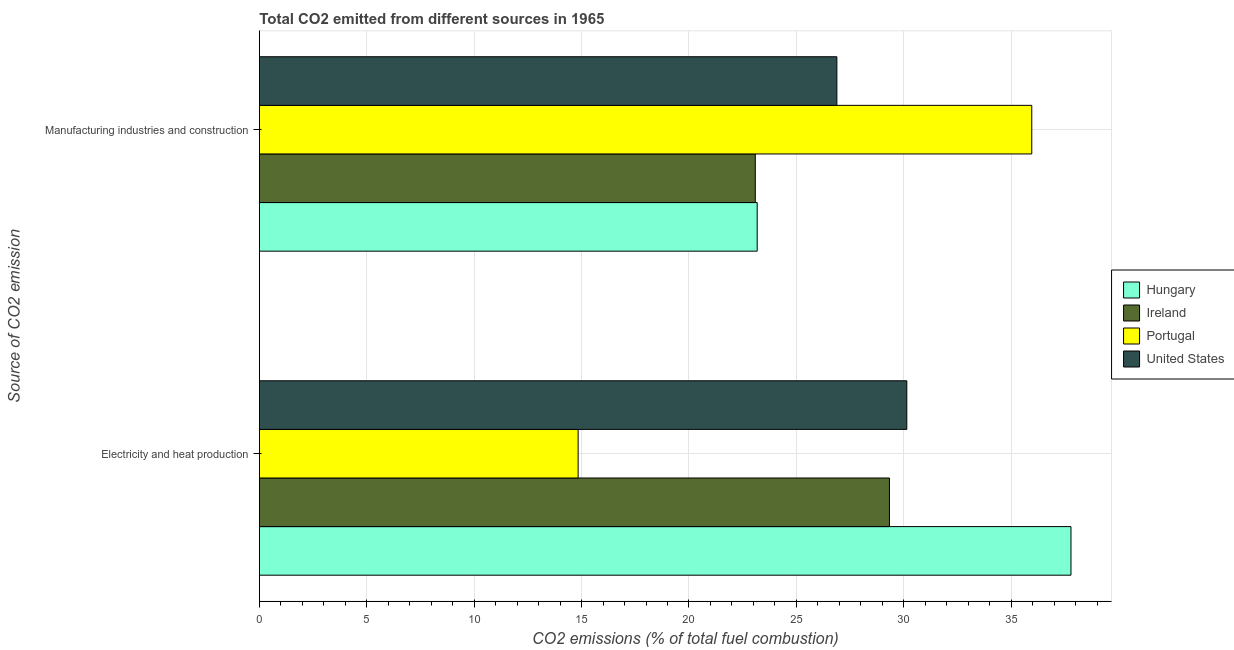How many groups of bars are there?
Provide a short and direct response. 2. How many bars are there on the 2nd tick from the top?
Give a very brief answer. 4. How many bars are there on the 2nd tick from the bottom?
Give a very brief answer. 4. What is the label of the 2nd group of bars from the top?
Offer a terse response. Electricity and heat production. What is the co2 emissions due to electricity and heat production in United States?
Provide a short and direct response. 30.14. Across all countries, what is the maximum co2 emissions due to manufacturing industries?
Your answer should be very brief. 35.96. Across all countries, what is the minimum co2 emissions due to manufacturing industries?
Offer a very short reply. 23.09. In which country was the co2 emissions due to electricity and heat production maximum?
Ensure brevity in your answer.  Hungary. In which country was the co2 emissions due to manufacturing industries minimum?
Provide a succinct answer. Ireland. What is the total co2 emissions due to manufacturing industries in the graph?
Keep it short and to the point. 109.11. What is the difference between the co2 emissions due to electricity and heat production in Ireland and that in United States?
Offer a terse response. -0.81. What is the difference between the co2 emissions due to electricity and heat production in Ireland and the co2 emissions due to manufacturing industries in Portugal?
Offer a terse response. -6.63. What is the average co2 emissions due to manufacturing industries per country?
Ensure brevity in your answer.  27.28. What is the difference between the co2 emissions due to manufacturing industries and co2 emissions due to electricity and heat production in United States?
Offer a very short reply. -3.26. In how many countries, is the co2 emissions due to manufacturing industries greater than 4 %?
Your answer should be compact. 4. What is the ratio of the co2 emissions due to manufacturing industries in Portugal to that in Ireland?
Give a very brief answer. 1.56. Is the co2 emissions due to electricity and heat production in United States less than that in Hungary?
Keep it short and to the point. Yes. What does the 4th bar from the top in Manufacturing industries and construction represents?
Give a very brief answer. Hungary. What does the 4th bar from the bottom in Manufacturing industries and construction represents?
Keep it short and to the point. United States. Are all the bars in the graph horizontal?
Your answer should be compact. Yes. How are the legend labels stacked?
Offer a terse response. Vertical. What is the title of the graph?
Make the answer very short. Total CO2 emitted from different sources in 1965. Does "Mozambique" appear as one of the legend labels in the graph?
Your answer should be compact. No. What is the label or title of the X-axis?
Provide a short and direct response. CO2 emissions (% of total fuel combustion). What is the label or title of the Y-axis?
Provide a short and direct response. Source of CO2 emission. What is the CO2 emissions (% of total fuel combustion) in Hungary in Electricity and heat production?
Give a very brief answer. 37.78. What is the CO2 emissions (% of total fuel combustion) in Ireland in Electricity and heat production?
Ensure brevity in your answer.  29.33. What is the CO2 emissions (% of total fuel combustion) of Portugal in Electricity and heat production?
Provide a succinct answer. 14.84. What is the CO2 emissions (% of total fuel combustion) in United States in Electricity and heat production?
Ensure brevity in your answer.  30.14. What is the CO2 emissions (% of total fuel combustion) of Hungary in Manufacturing industries and construction?
Keep it short and to the point. 23.18. What is the CO2 emissions (% of total fuel combustion) of Ireland in Manufacturing industries and construction?
Provide a succinct answer. 23.09. What is the CO2 emissions (% of total fuel combustion) in Portugal in Manufacturing industries and construction?
Your response must be concise. 35.96. What is the CO2 emissions (% of total fuel combustion) in United States in Manufacturing industries and construction?
Offer a very short reply. 26.89. Across all Source of CO2 emission, what is the maximum CO2 emissions (% of total fuel combustion) of Hungary?
Ensure brevity in your answer.  37.78. Across all Source of CO2 emission, what is the maximum CO2 emissions (% of total fuel combustion) of Ireland?
Your answer should be very brief. 29.33. Across all Source of CO2 emission, what is the maximum CO2 emissions (% of total fuel combustion) in Portugal?
Your response must be concise. 35.96. Across all Source of CO2 emission, what is the maximum CO2 emissions (% of total fuel combustion) in United States?
Your answer should be very brief. 30.14. Across all Source of CO2 emission, what is the minimum CO2 emissions (% of total fuel combustion) in Hungary?
Offer a terse response. 23.18. Across all Source of CO2 emission, what is the minimum CO2 emissions (% of total fuel combustion) of Ireland?
Offer a very short reply. 23.09. Across all Source of CO2 emission, what is the minimum CO2 emissions (% of total fuel combustion) of Portugal?
Give a very brief answer. 14.84. Across all Source of CO2 emission, what is the minimum CO2 emissions (% of total fuel combustion) of United States?
Your answer should be very brief. 26.89. What is the total CO2 emissions (% of total fuel combustion) of Hungary in the graph?
Provide a succinct answer. 60.96. What is the total CO2 emissions (% of total fuel combustion) of Ireland in the graph?
Make the answer very short. 52.42. What is the total CO2 emissions (% of total fuel combustion) in Portugal in the graph?
Give a very brief answer. 50.8. What is the total CO2 emissions (% of total fuel combustion) in United States in the graph?
Make the answer very short. 57.03. What is the difference between the CO2 emissions (% of total fuel combustion) in Hungary in Electricity and heat production and that in Manufacturing industries and construction?
Provide a short and direct response. 14.61. What is the difference between the CO2 emissions (% of total fuel combustion) of Ireland in Electricity and heat production and that in Manufacturing industries and construction?
Keep it short and to the point. 6.25. What is the difference between the CO2 emissions (% of total fuel combustion) in Portugal in Electricity and heat production and that in Manufacturing industries and construction?
Provide a short and direct response. -21.12. What is the difference between the CO2 emissions (% of total fuel combustion) of United States in Electricity and heat production and that in Manufacturing industries and construction?
Offer a very short reply. 3.26. What is the difference between the CO2 emissions (% of total fuel combustion) in Hungary in Electricity and heat production and the CO2 emissions (% of total fuel combustion) in Ireland in Manufacturing industries and construction?
Provide a succinct answer. 14.7. What is the difference between the CO2 emissions (% of total fuel combustion) of Hungary in Electricity and heat production and the CO2 emissions (% of total fuel combustion) of Portugal in Manufacturing industries and construction?
Ensure brevity in your answer.  1.83. What is the difference between the CO2 emissions (% of total fuel combustion) of Hungary in Electricity and heat production and the CO2 emissions (% of total fuel combustion) of United States in Manufacturing industries and construction?
Give a very brief answer. 10.9. What is the difference between the CO2 emissions (% of total fuel combustion) of Ireland in Electricity and heat production and the CO2 emissions (% of total fuel combustion) of Portugal in Manufacturing industries and construction?
Ensure brevity in your answer.  -6.63. What is the difference between the CO2 emissions (% of total fuel combustion) of Ireland in Electricity and heat production and the CO2 emissions (% of total fuel combustion) of United States in Manufacturing industries and construction?
Your answer should be very brief. 2.45. What is the difference between the CO2 emissions (% of total fuel combustion) of Portugal in Electricity and heat production and the CO2 emissions (% of total fuel combustion) of United States in Manufacturing industries and construction?
Your answer should be compact. -12.05. What is the average CO2 emissions (% of total fuel combustion) of Hungary per Source of CO2 emission?
Make the answer very short. 30.48. What is the average CO2 emissions (% of total fuel combustion) of Ireland per Source of CO2 emission?
Provide a short and direct response. 26.21. What is the average CO2 emissions (% of total fuel combustion) of Portugal per Source of CO2 emission?
Offer a very short reply. 25.4. What is the average CO2 emissions (% of total fuel combustion) in United States per Source of CO2 emission?
Your response must be concise. 28.51. What is the difference between the CO2 emissions (% of total fuel combustion) in Hungary and CO2 emissions (% of total fuel combustion) in Ireland in Electricity and heat production?
Keep it short and to the point. 8.45. What is the difference between the CO2 emissions (% of total fuel combustion) in Hungary and CO2 emissions (% of total fuel combustion) in Portugal in Electricity and heat production?
Offer a terse response. 22.94. What is the difference between the CO2 emissions (% of total fuel combustion) in Hungary and CO2 emissions (% of total fuel combustion) in United States in Electricity and heat production?
Your answer should be compact. 7.64. What is the difference between the CO2 emissions (% of total fuel combustion) of Ireland and CO2 emissions (% of total fuel combustion) of Portugal in Electricity and heat production?
Your answer should be very brief. 14.49. What is the difference between the CO2 emissions (% of total fuel combustion) in Ireland and CO2 emissions (% of total fuel combustion) in United States in Electricity and heat production?
Make the answer very short. -0.81. What is the difference between the CO2 emissions (% of total fuel combustion) of Portugal and CO2 emissions (% of total fuel combustion) of United States in Electricity and heat production?
Your answer should be very brief. -15.3. What is the difference between the CO2 emissions (% of total fuel combustion) in Hungary and CO2 emissions (% of total fuel combustion) in Ireland in Manufacturing industries and construction?
Ensure brevity in your answer.  0.09. What is the difference between the CO2 emissions (% of total fuel combustion) in Hungary and CO2 emissions (% of total fuel combustion) in Portugal in Manufacturing industries and construction?
Offer a terse response. -12.78. What is the difference between the CO2 emissions (% of total fuel combustion) of Hungary and CO2 emissions (% of total fuel combustion) of United States in Manufacturing industries and construction?
Offer a very short reply. -3.71. What is the difference between the CO2 emissions (% of total fuel combustion) in Ireland and CO2 emissions (% of total fuel combustion) in Portugal in Manufacturing industries and construction?
Give a very brief answer. -12.87. What is the difference between the CO2 emissions (% of total fuel combustion) in Ireland and CO2 emissions (% of total fuel combustion) in United States in Manufacturing industries and construction?
Offer a terse response. -3.8. What is the difference between the CO2 emissions (% of total fuel combustion) of Portugal and CO2 emissions (% of total fuel combustion) of United States in Manufacturing industries and construction?
Provide a succinct answer. 9.07. What is the ratio of the CO2 emissions (% of total fuel combustion) of Hungary in Electricity and heat production to that in Manufacturing industries and construction?
Your answer should be very brief. 1.63. What is the ratio of the CO2 emissions (% of total fuel combustion) in Ireland in Electricity and heat production to that in Manufacturing industries and construction?
Provide a short and direct response. 1.27. What is the ratio of the CO2 emissions (% of total fuel combustion) of Portugal in Electricity and heat production to that in Manufacturing industries and construction?
Your answer should be very brief. 0.41. What is the ratio of the CO2 emissions (% of total fuel combustion) of United States in Electricity and heat production to that in Manufacturing industries and construction?
Ensure brevity in your answer.  1.12. What is the difference between the highest and the second highest CO2 emissions (% of total fuel combustion) of Hungary?
Provide a succinct answer. 14.61. What is the difference between the highest and the second highest CO2 emissions (% of total fuel combustion) in Ireland?
Your answer should be very brief. 6.25. What is the difference between the highest and the second highest CO2 emissions (% of total fuel combustion) in Portugal?
Provide a short and direct response. 21.12. What is the difference between the highest and the second highest CO2 emissions (% of total fuel combustion) of United States?
Make the answer very short. 3.26. What is the difference between the highest and the lowest CO2 emissions (% of total fuel combustion) in Hungary?
Provide a succinct answer. 14.61. What is the difference between the highest and the lowest CO2 emissions (% of total fuel combustion) of Ireland?
Make the answer very short. 6.25. What is the difference between the highest and the lowest CO2 emissions (% of total fuel combustion) in Portugal?
Give a very brief answer. 21.12. What is the difference between the highest and the lowest CO2 emissions (% of total fuel combustion) of United States?
Give a very brief answer. 3.26. 